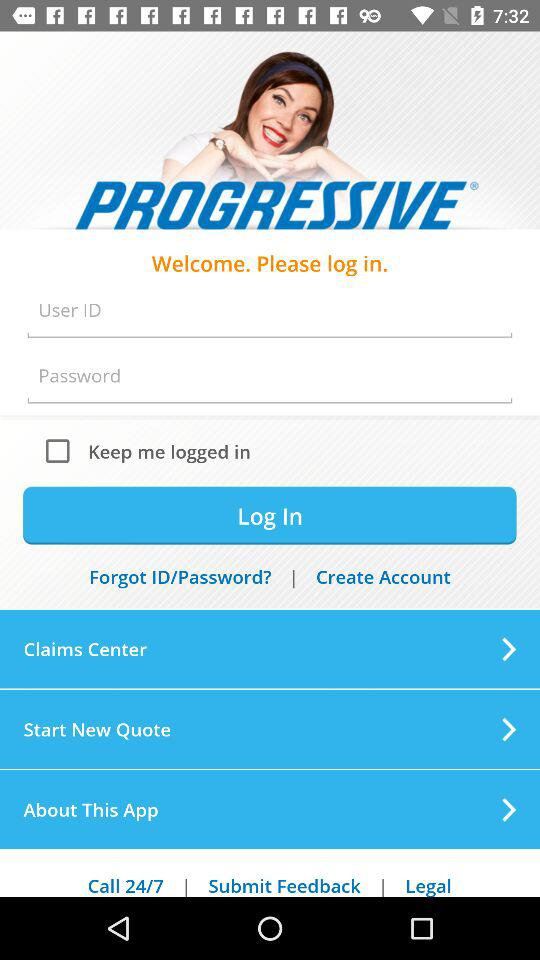What is the app name? The app name is "PROGRESSIVE". 